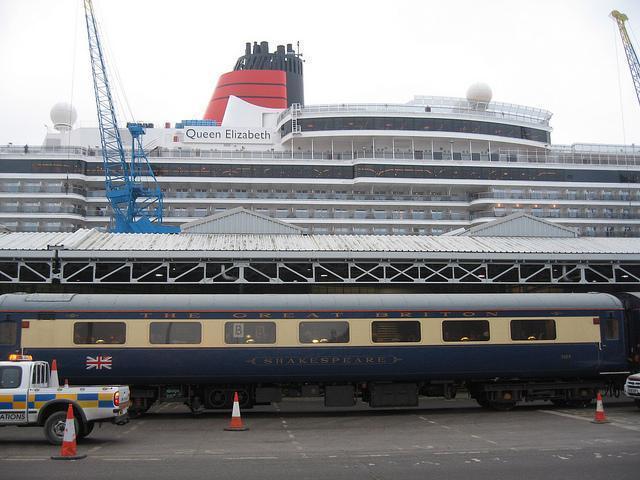The person whose name appears at the top is a descendant of whom?
Choose the right answer from the provided options to respond to the question.
Options: Atahualpa, henry viii, saladin, temujin. Henry viii. 